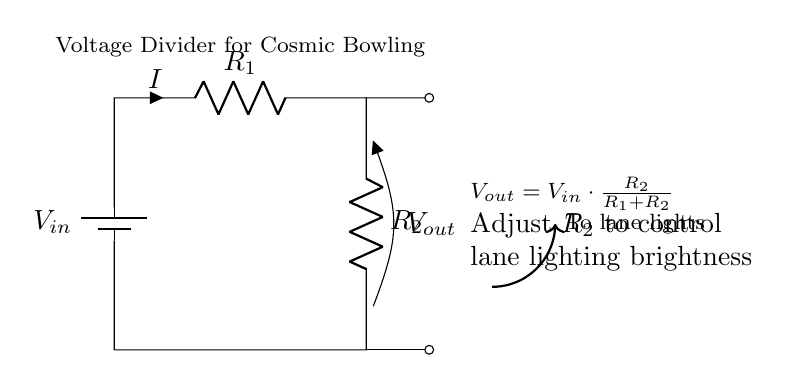What is the input voltage? The input voltage is labeled as \( V_{in} \) in the circuit diagram. It represents the total voltage supplied to the circuit from the battery.
Answer: \( V_{in} \) What does \( V_{out} \) represent? \( V_{out} \) is the output voltage across resistor \( R_2 \). It indicates the voltage level that is supplied to the lane lights, influencing their brightness.
Answer: \( V_{out} \) How can you adjust lane lighting brightness? Lane lighting brightness can be adjusted by changing the resistance value of \( R_2 \). Since \( V_{out} \) is dependent on the ratio of \( R_2 \) to the total resistance of \( R_1 + R_2 \), this adjustment will control the output voltage and thus the brightness.
Answer: Adjust \( R_2 \) What is the formula for \( V_{out} \)? The formula shown in the diagram states that \( V_{out} = V_{in} \cdot \frac{R_2}{R_1 + R_2} \). This equation summarizes how the output voltage is derived based on the input voltage and resistance values.
Answer: \( V_{out} = V_{in} \cdot \frac{R_2}{R_1 + R_2} \) What happens if \( R_1 \) is increased? Increasing \( R_1 \) while keeping \( R_2 \) constant will decrease the output voltage \( V_{out} \). This happens because a higher \( R_1 \) increases the total resistance, resulting in a smaller fraction of \( V_{in} \) appearing across \( R_2 \).
Answer: \( V_{out} \) decreases Which component does the current \( I \) flow through first? The current \( I \) flows through \( R_1 \) first, as depicted in the circuit. The arrangement shows that current flows from the battery through \( R_1 \) before reaching \( R_2 \).
Answer: \( R_1 \) What is the purpose of the voltage divider in this circuit? The voltage divider's purpose in this circuit is to provide a specific output voltage \( V_{out} \) to control the brightness of the lane lights during cosmic bowling events. This allows for an adjustable lighting effect.
Answer: Control lane lighting brightness 